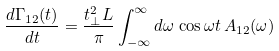Convert formula to latex. <formula><loc_0><loc_0><loc_500><loc_500>\frac { d \Gamma _ { 1 2 } ( t ) } { d t } = \frac { t _ { \perp } ^ { 2 } L } { \pi } \int _ { - \infty } ^ { \infty } d \omega \, \cos \omega t \, A _ { 1 2 } ( \omega )</formula> 